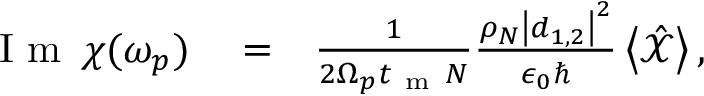<formula> <loc_0><loc_0><loc_500><loc_500>\begin{array} { r l r } { I m \, \chi ( \omega _ { p } ) } & = } & { \frac { 1 } { 2 \Omega _ { p } t _ { m } N } \frac { \rho _ { N } \left | \boldsymbol d _ { 1 , 2 } \right | ^ { 2 } } { \epsilon _ { 0 } } \left < \hat { \mathcal { X } } \right > , } \end{array}</formula> 